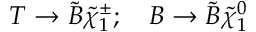<formula> <loc_0><loc_0><loc_500><loc_500>T \rightarrow \tilde { B } { \tilde { \chi } } _ { 1 } ^ { \pm } ; \quad B \rightarrow \tilde { B } { \tilde { \chi } } _ { 1 } ^ { 0 }</formula> 